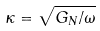Convert formula to latex. <formula><loc_0><loc_0><loc_500><loc_500>\kappa = { \sqrt { G _ { N } / \omega } }</formula> 